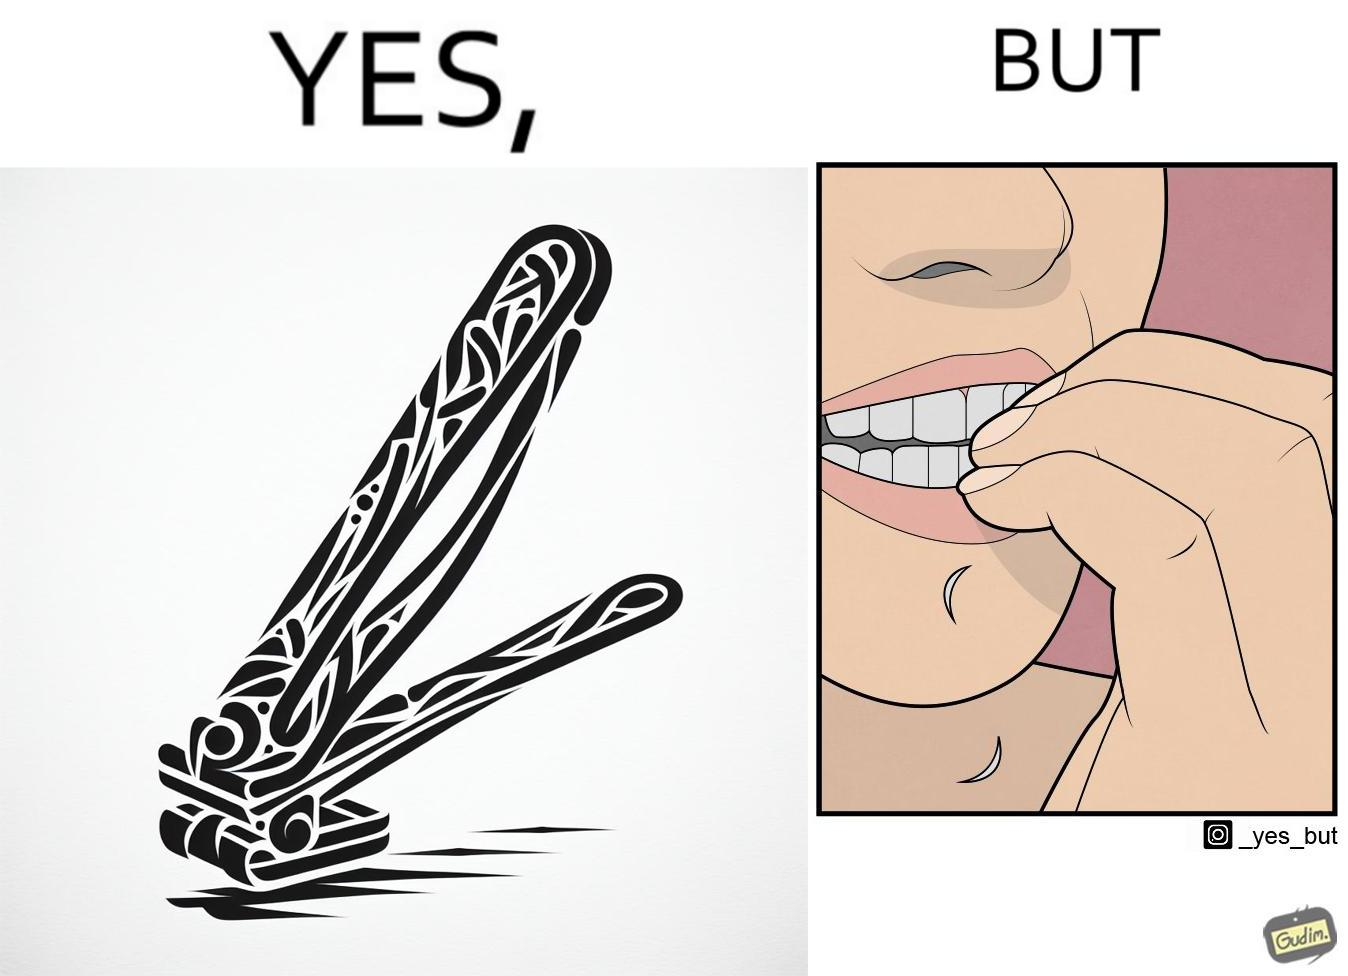What is shown in this image? The image is ironic, because even after nail clippers are available people prefer biting their nails by teeth 